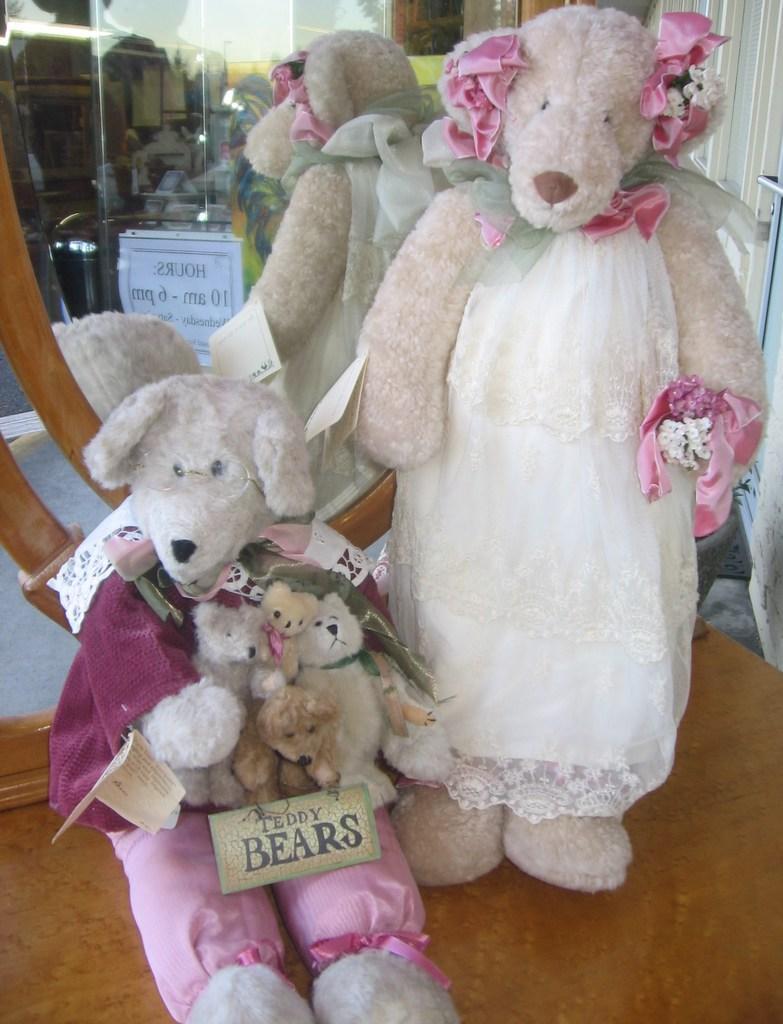Could you give a brief overview of what you see in this image? In this picture I can see there are two teddy bears and and there is a mirror in the backdrop. There is a curtain on to the right side. 